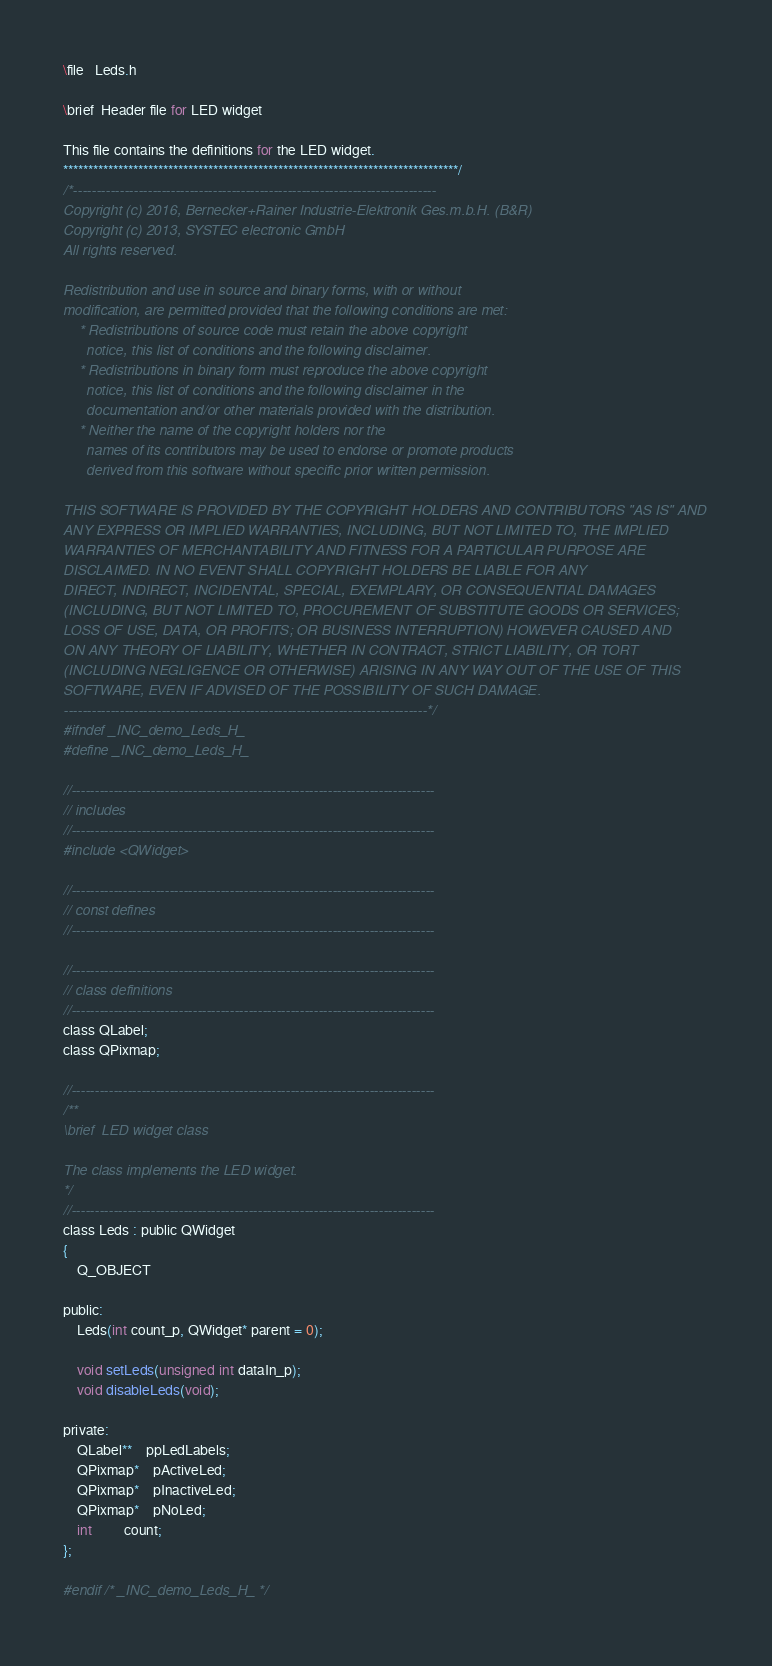Convert code to text. <code><loc_0><loc_0><loc_500><loc_500><_C_>\file   Leds.h

\brief  Header file for LED widget

This file contains the definitions for the LED widget.
*******************************************************************************/
/*------------------------------------------------------------------------------
Copyright (c) 2016, Bernecker+Rainer Industrie-Elektronik Ges.m.b.H. (B&R)
Copyright (c) 2013, SYSTEC electronic GmbH
All rights reserved.

Redistribution and use in source and binary forms, with or without
modification, are permitted provided that the following conditions are met:
    * Redistributions of source code must retain the above copyright
      notice, this list of conditions and the following disclaimer.
    * Redistributions in binary form must reproduce the above copyright
      notice, this list of conditions and the following disclaimer in the
      documentation and/or other materials provided with the distribution.
    * Neither the name of the copyright holders nor the
      names of its contributors may be used to endorse or promote products
      derived from this software without specific prior written permission.

THIS SOFTWARE IS PROVIDED BY THE COPYRIGHT HOLDERS AND CONTRIBUTORS "AS IS" AND
ANY EXPRESS OR IMPLIED WARRANTIES, INCLUDING, BUT NOT LIMITED TO, THE IMPLIED
WARRANTIES OF MERCHANTABILITY AND FITNESS FOR A PARTICULAR PURPOSE ARE
DISCLAIMED. IN NO EVENT SHALL COPYRIGHT HOLDERS BE LIABLE FOR ANY
DIRECT, INDIRECT, INCIDENTAL, SPECIAL, EXEMPLARY, OR CONSEQUENTIAL DAMAGES
(INCLUDING, BUT NOT LIMITED TO, PROCUREMENT OF SUBSTITUTE GOODS OR SERVICES;
LOSS OF USE, DATA, OR PROFITS; OR BUSINESS INTERRUPTION) HOWEVER CAUSED AND
ON ANY THEORY OF LIABILITY, WHETHER IN CONTRACT, STRICT LIABILITY, OR TORT
(INCLUDING NEGLIGENCE OR OTHERWISE) ARISING IN ANY WAY OUT OF THE USE OF THIS
SOFTWARE, EVEN IF ADVISED OF THE POSSIBILITY OF SUCH DAMAGE.
------------------------------------------------------------------------------*/
#ifndef _INC_demo_Leds_H_
#define _INC_demo_Leds_H_

//------------------------------------------------------------------------------
// includes
//------------------------------------------------------------------------------
#include <QWidget>

//------------------------------------------------------------------------------
// const defines
//------------------------------------------------------------------------------

//------------------------------------------------------------------------------
// class definitions
//------------------------------------------------------------------------------
class QLabel;
class QPixmap;

//------------------------------------------------------------------------------
/**
\brief  LED widget class

The class implements the LED widget.
*/
//------------------------------------------------------------------------------
class Leds : public QWidget
{
    Q_OBJECT

public:
    Leds(int count_p, QWidget* parent = 0);

    void setLeds(unsigned int dataIn_p);
    void disableLeds(void);

private:
    QLabel**    ppLedLabels;
    QPixmap*    pActiveLed;
    QPixmap*    pInactiveLed;
    QPixmap*    pNoLed;
    int         count;
};

#endif /* _INC_demo_Leds_H_ */
</code> 